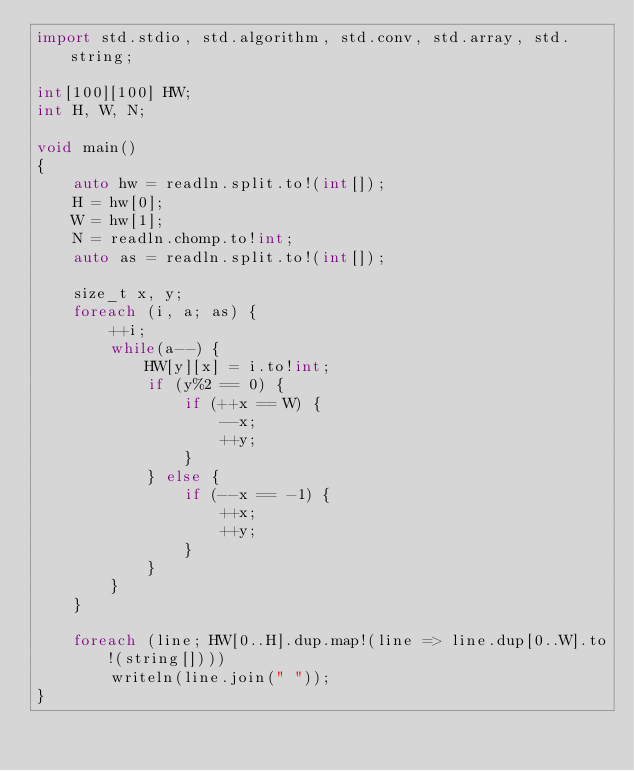Convert code to text. <code><loc_0><loc_0><loc_500><loc_500><_D_>import std.stdio, std.algorithm, std.conv, std.array, std.string;

int[100][100] HW;
int H, W, N;

void main()
{
    auto hw = readln.split.to!(int[]);
    H = hw[0];
    W = hw[1];
    N = readln.chomp.to!int;
    auto as = readln.split.to!(int[]);

    size_t x, y;
    foreach (i, a; as) {
        ++i;
        while(a--) {
            HW[y][x] = i.to!int;
            if (y%2 == 0) {
                if (++x == W) {
                    --x;
                    ++y;
                }
            } else {
                if (--x == -1) {
                    ++x;
                    ++y;
                }
            }
        }
    }

    foreach (line; HW[0..H].dup.map!(line => line.dup[0..W].to!(string[])))
        writeln(line.join(" "));
}</code> 